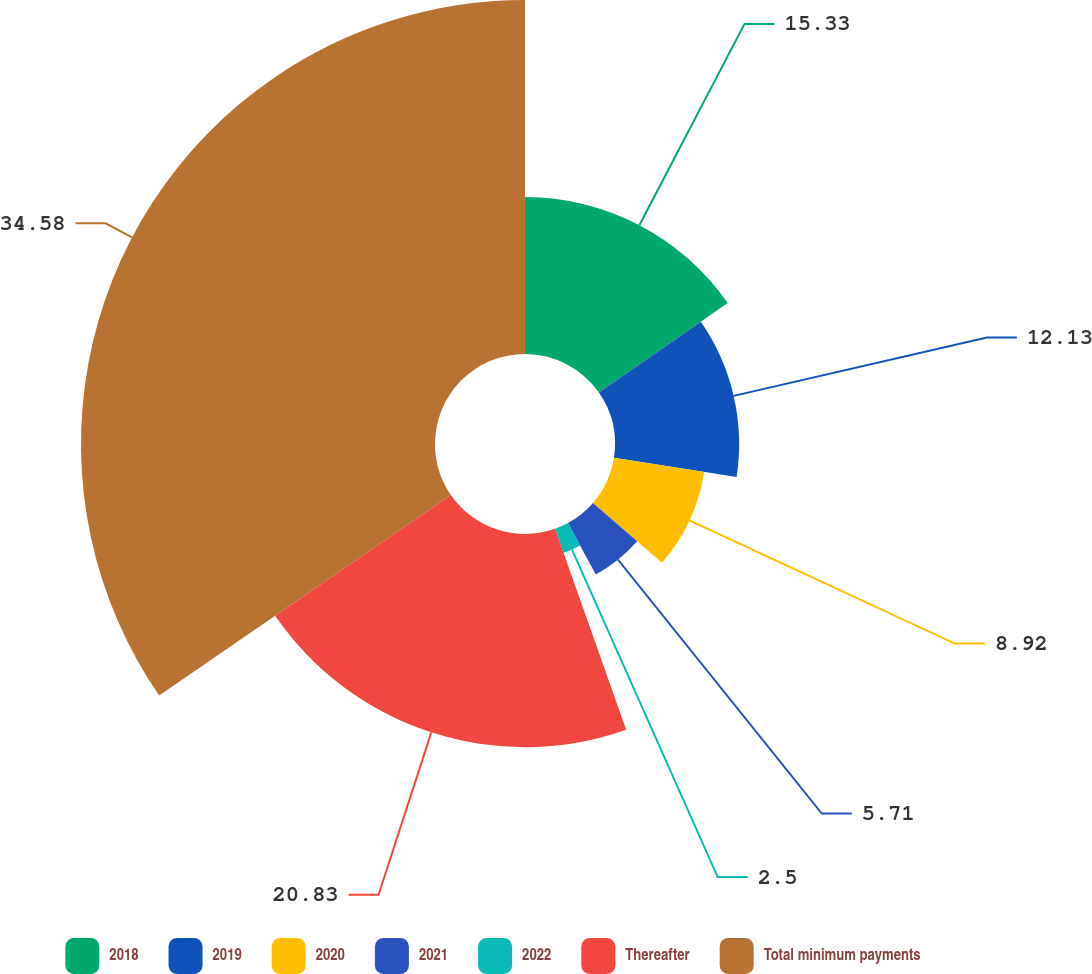Convert chart to OTSL. <chart><loc_0><loc_0><loc_500><loc_500><pie_chart><fcel>2018<fcel>2019<fcel>2020<fcel>2021<fcel>2022<fcel>Thereafter<fcel>Total minimum payments<nl><fcel>15.33%<fcel>12.13%<fcel>8.92%<fcel>5.71%<fcel>2.5%<fcel>20.83%<fcel>34.59%<nl></chart> 